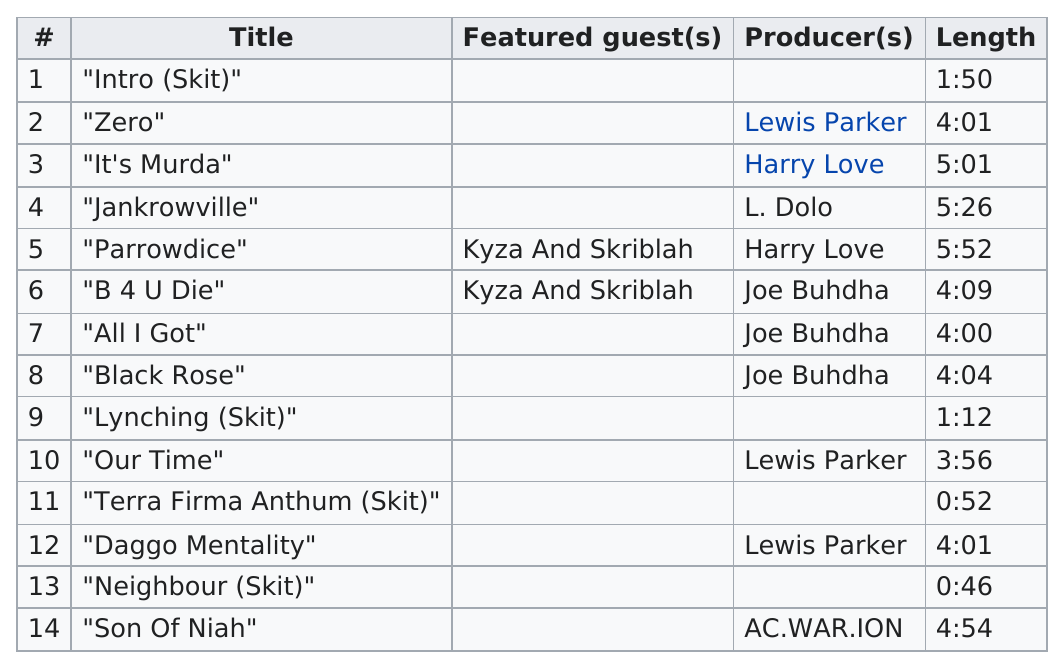Draw attention to some important aspects in this diagram. Joe Bhdha has produced a total of 3 songs. There were 10 tracks that were at least 3 minutes or more in length. The Sagas of Norns contains 10 songs in total. It's Murda" is longer in terms of time compared to "Son of Nihal. The track that followed "Our Time" on the album was "Terra Firma Anthum (Skit)," as confirmed in the lyrics provided. 